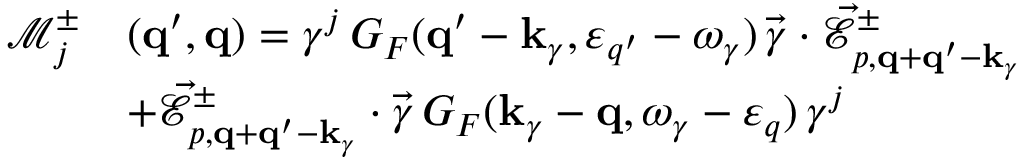Convert formula to latex. <formula><loc_0><loc_0><loc_500><loc_500>\begin{array} { r l } { \mathcal { M } _ { j } ^ { \pm } } & { ( { q } ^ { \prime } , { q } ) = \gamma ^ { j } \, G _ { F } ( { q } ^ { \prime } - { k } _ { \gamma } , \varepsilon _ { q ^ { \prime } } - \omega _ { \gamma } ) \, \vec { \gamma } \cdot \vec { \mathcal { E } } _ { p , { q } + { q } ^ { \prime } - { k } _ { \gamma } } ^ { \pm } } \\ & { + \vec { \mathcal { E } } _ { p , { q } + { q } ^ { \prime } - { k } _ { \gamma } } ^ { \pm } \cdot \vec { \gamma } \, G _ { F } ( { k } _ { \gamma } - { q } , \omega _ { \gamma } - \varepsilon _ { q } ) \, \gamma ^ { j } } \end{array}</formula> 